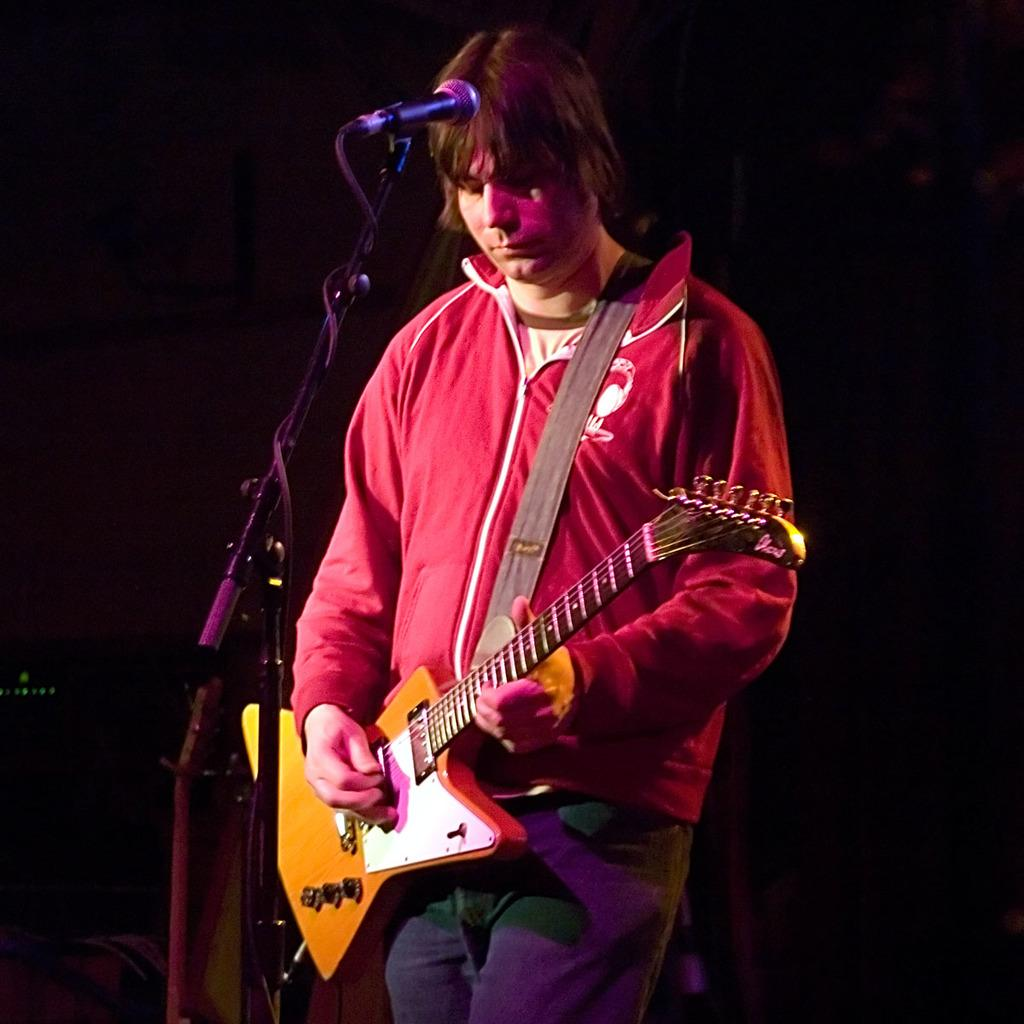What is the main subject of the image? The main subject of the image is a man standing in the center. What is the man holding in the image? The man is holding a musical instrument. Can you describe the setup in front of the man? There is a stand in front of the man. What device is present for amplifying sound in the image? There is a microphone (mic) in the image. What type of tramp can be seen in the image? There is no tramp present in the image. Is the man in the image reading a book? There is no book visible in the image, and the man is holding a musical instrument, not reading. 